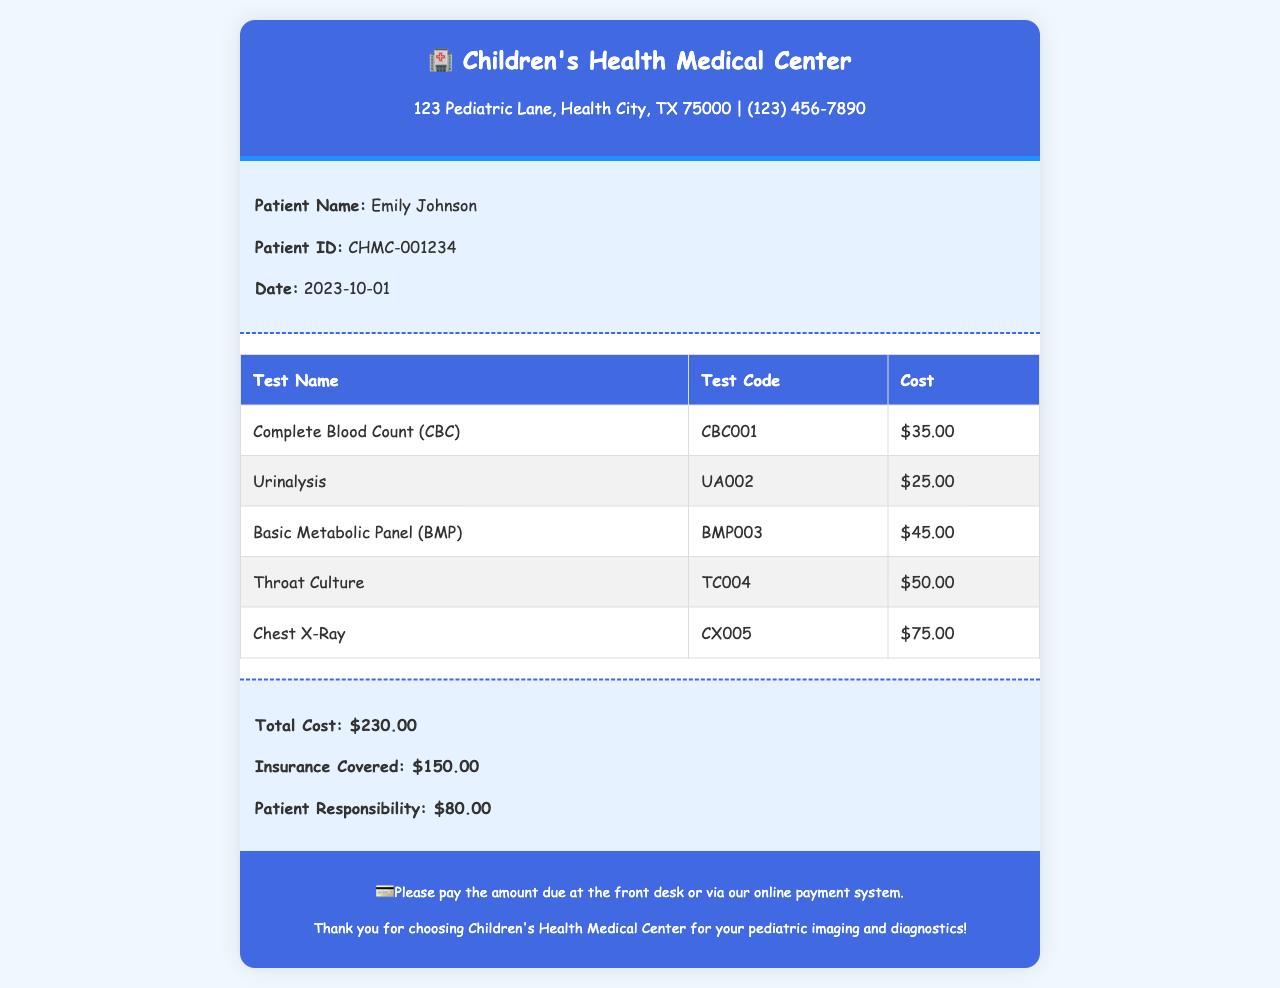What is the patient's name? The receipt includes a section that identifies the patient's name as Emily Johnson.
Answer: Emily Johnson What is the date of the receipt? The document specifies the date of service and is stated clearly in the patient info section.
Answer: 2023-10-01 How much does the Chest X-Ray cost? The costs for individual tests are listed in the table, specifically showing the price for the Chest X-Ray.
Answer: $75.00 What is the total cost of the tests performed? The summary section provides the combined cost of all tests performed for the patient.
Answer: $230.00 How much is the patient responsible for after insurance? The receipt clearly outlines the patient responsibility amount after considering insurance coverage.
Answer: $80.00 What is the insurance coverage amount? The receipt indicates the total amount that the insurance company will cover, which is listed in the summary.
Answer: $150.00 What is the test code for Urinalysis? The test codes for all tests are provided in the tests table, including the one for Urinalysis.
Answer: UA002 What kind of facility issued this receipt? The header of the document identifies the name of the issuing healthcare facility.
Answer: Children's Health Medical Center What information is included in the footer? The footer provides instructions regarding payment and a thank you message from the facility.
Answer: Payment instructions and thank you message 